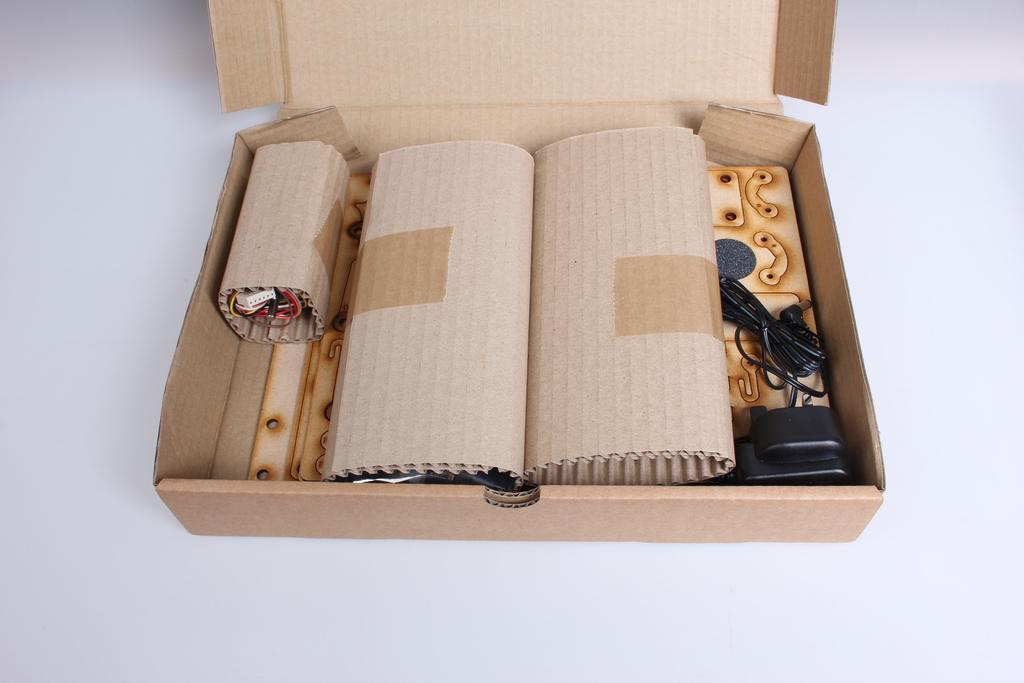How would you summarize this image in a sentence or two? In this image I can see the cardboard box. In the cardboard box I can see the black color charger, an object in the cardboard sheet and few more sheets. I can see the cardboard box on the white color surface. 